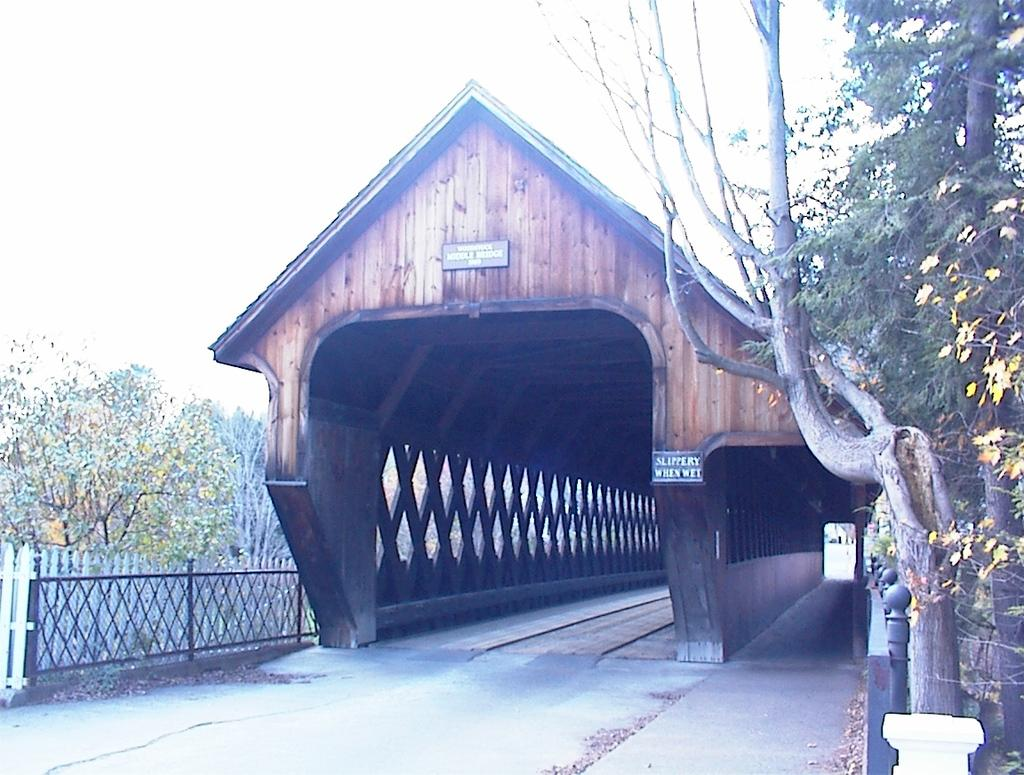What structure can be seen in the image? There is a shed in the image. Where is the shed located in relation to the ground? The shed is positioned over a place. What can be seen on the left side of the image? There is a railing on the left side of the image. What type of vegetation is present in the image? Plants and trees are visible in the image. What type of room is visible in the image? There is no room visible in the image; it features a shed, railing, plants, and trees. 